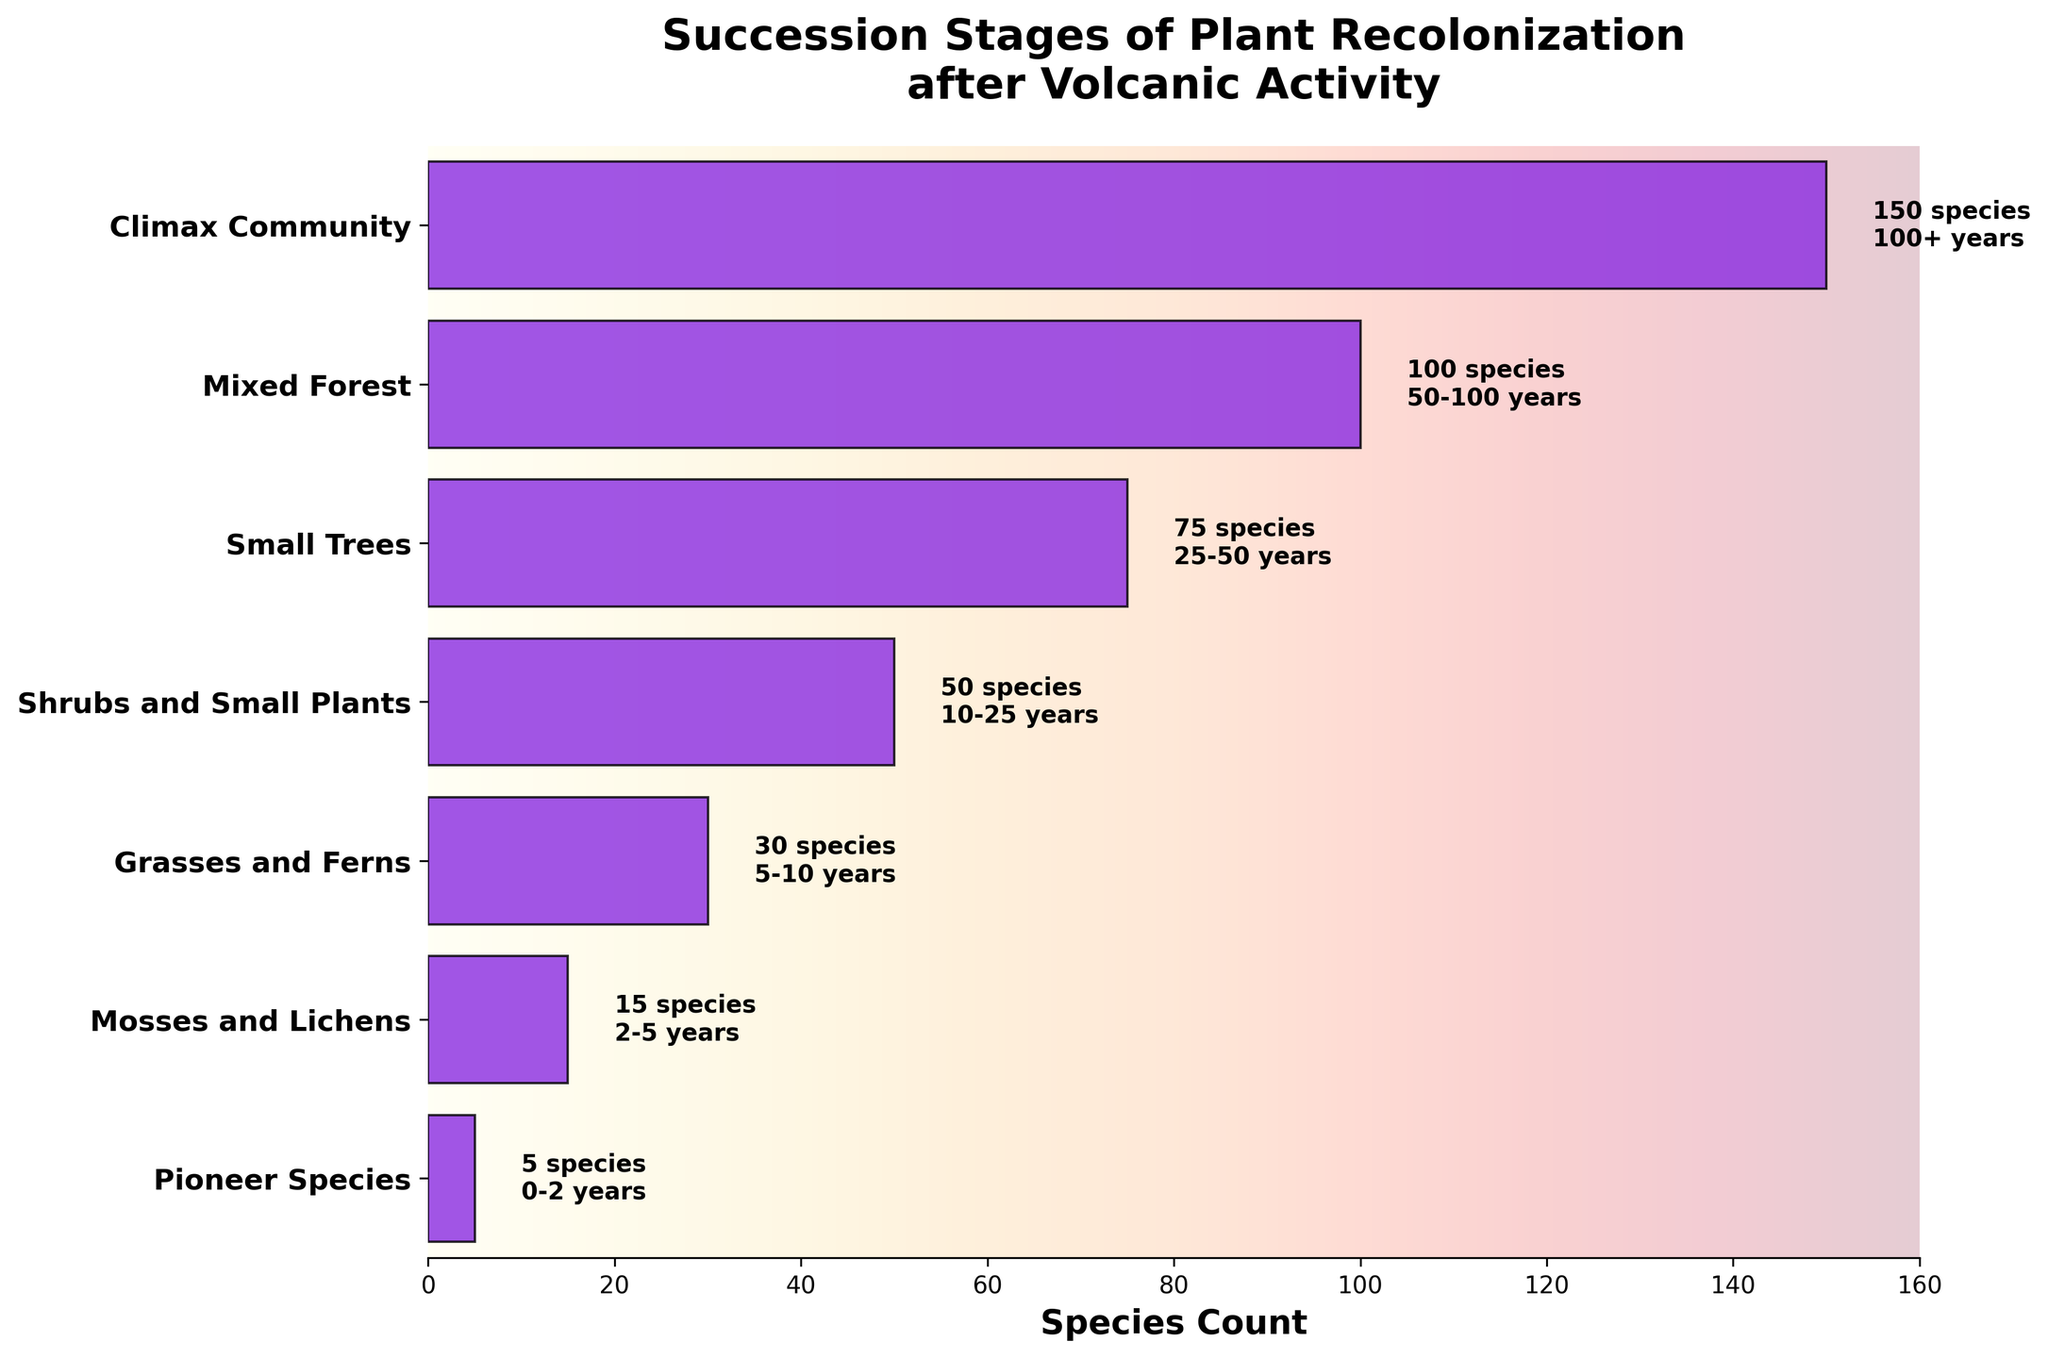What's the title of the plot? Look at the top section of the plot where the title is usually placed.
Answer: Succession Stages of Plant Recolonization after Volcanic Activity How many species are represented in the Mosses and Lichens stage? Refer to the bar corresponding to the "Mosses and Lichens" stage and find the species count labeled on the bar.
Answer: 15 Which stage has the highest species count? Compare the lengths of the bars or look at the species count labels for each stage.
Answer: Climax Community What is the time range for the Small Trees stage? Look at the time label next to the bar for the "Small Trees" stage.
Answer: 25-50 years How does the species count change from the Shrubs and Small Plants stage to the Small Trees stage? Subtract the species count of the "Shrubs and Small Plants" stage from the "Small Trees" stage.
Answer: Increase by 25 What is the average species count for the first three stages? Add the species counts of the first three stages and divide by 3.
Answer: (5 + 15 + 30) / 3 = 50 / 3 = 16.67 Which stage follows the Grasses and Ferns stage in the succession? Look at the next stage in the vertical sequence after "Grasses and Ferns".
Answer: Shrubs and Small Plants Compare the species count between the Mixed Forest stage and the Climax Community stage. Subtract the species count of the Mixed Forest stage from the Climax Community stage.
Answer: 150 - 100 = 50 What is the species count for Pioneer Species compared to Small Trees? Subtract the species count of the "Pioneer Species" stage from the "Small Trees" stage.
Answer: 75 - 5 = 70 Arrange the stages in order of increasing species count. List the stages based on increasing species counts displayed on the bars.
Answer: Pioneer Species, Mosses and Lichens, Grasses and Ferns, Shrubs and Small Plants, Small Trees, Mixed Forest, Climax Community 